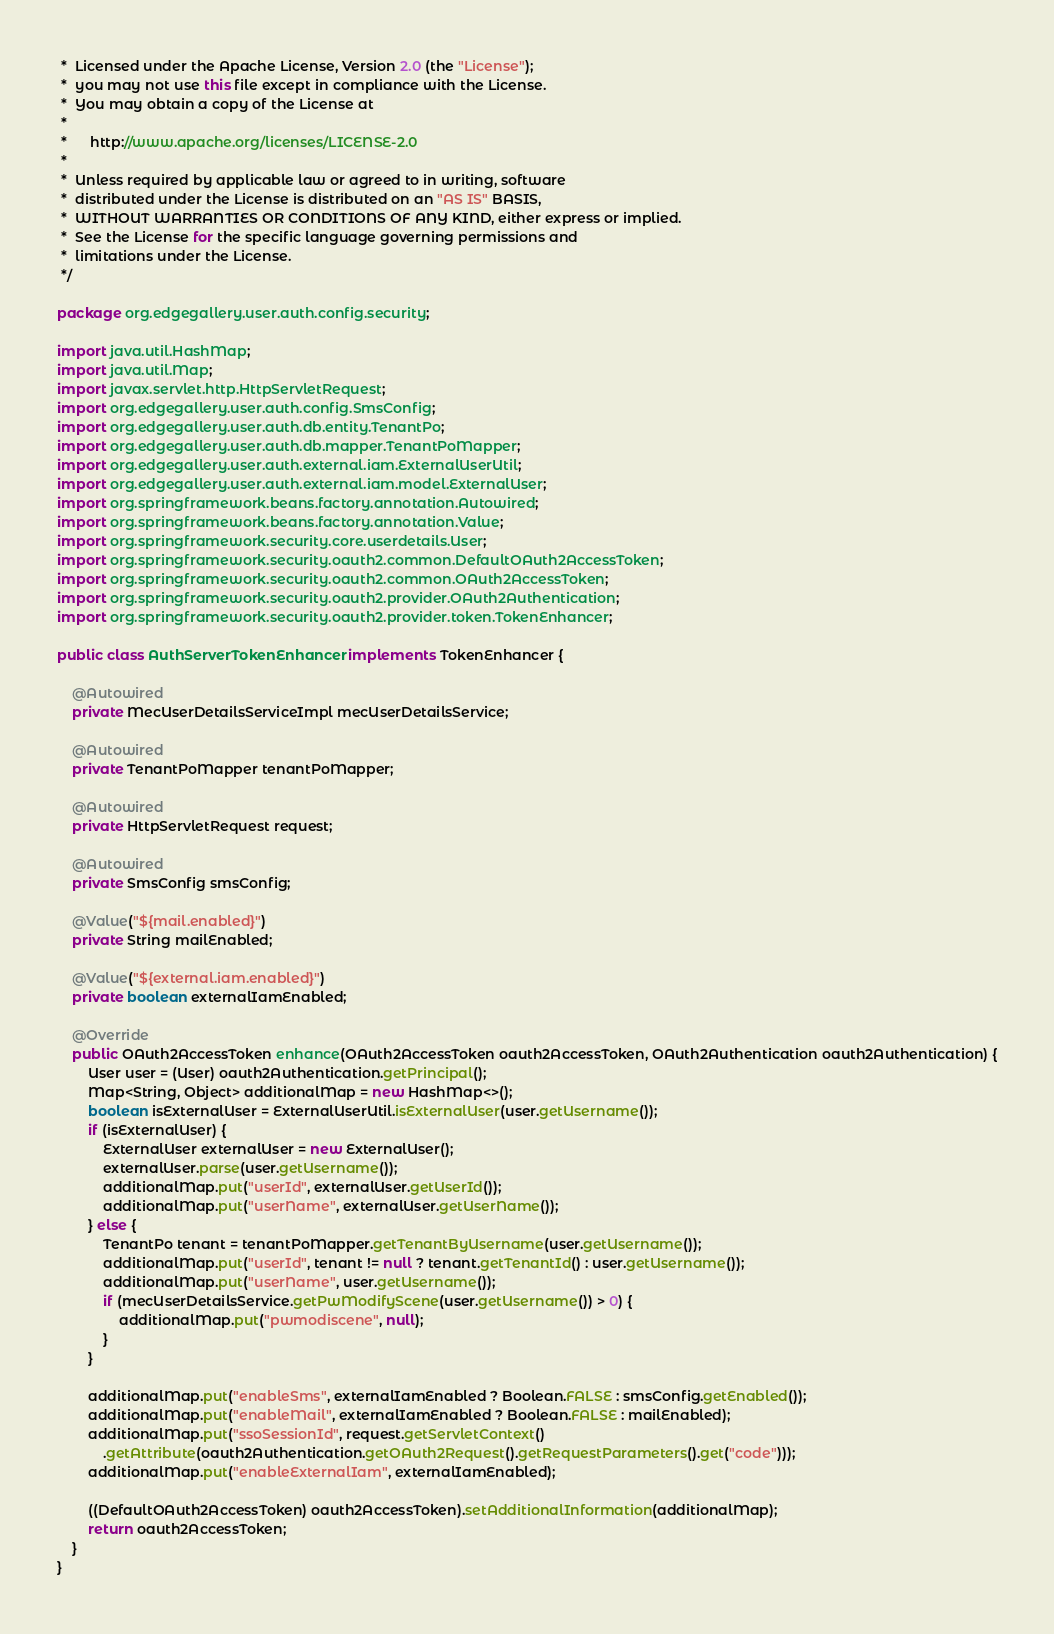Convert code to text. <code><loc_0><loc_0><loc_500><loc_500><_Java_> *  Licensed under the Apache License, Version 2.0 (the "License");
 *  you may not use this file except in compliance with the License.
 *  You may obtain a copy of the License at
 *
 *      http://www.apache.org/licenses/LICENSE-2.0
 *
 *  Unless required by applicable law or agreed to in writing, software
 *  distributed under the License is distributed on an "AS IS" BASIS,
 *  WITHOUT WARRANTIES OR CONDITIONS OF ANY KIND, either express or implied.
 *  See the License for the specific language governing permissions and
 *  limitations under the License.
 */

package org.edgegallery.user.auth.config.security;

import java.util.HashMap;
import java.util.Map;
import javax.servlet.http.HttpServletRequest;
import org.edgegallery.user.auth.config.SmsConfig;
import org.edgegallery.user.auth.db.entity.TenantPo;
import org.edgegallery.user.auth.db.mapper.TenantPoMapper;
import org.edgegallery.user.auth.external.iam.ExternalUserUtil;
import org.edgegallery.user.auth.external.iam.model.ExternalUser;
import org.springframework.beans.factory.annotation.Autowired;
import org.springframework.beans.factory.annotation.Value;
import org.springframework.security.core.userdetails.User;
import org.springframework.security.oauth2.common.DefaultOAuth2AccessToken;
import org.springframework.security.oauth2.common.OAuth2AccessToken;
import org.springframework.security.oauth2.provider.OAuth2Authentication;
import org.springframework.security.oauth2.provider.token.TokenEnhancer;

public class AuthServerTokenEnhancer implements TokenEnhancer {

    @Autowired
    private MecUserDetailsServiceImpl mecUserDetailsService;

    @Autowired
    private TenantPoMapper tenantPoMapper;

    @Autowired
    private HttpServletRequest request;

    @Autowired
    private SmsConfig smsConfig;

    @Value("${mail.enabled}")
    private String mailEnabled;

    @Value("${external.iam.enabled}")
    private boolean externalIamEnabled;

    @Override
    public OAuth2AccessToken enhance(OAuth2AccessToken oauth2AccessToken, OAuth2Authentication oauth2Authentication) {
        User user = (User) oauth2Authentication.getPrincipal();
        Map<String, Object> additionalMap = new HashMap<>();
        boolean isExternalUser = ExternalUserUtil.isExternalUser(user.getUsername());
        if (isExternalUser) {
            ExternalUser externalUser = new ExternalUser();
            externalUser.parse(user.getUsername());
            additionalMap.put("userId", externalUser.getUserId());
            additionalMap.put("userName", externalUser.getUserName());
        } else {
            TenantPo tenant = tenantPoMapper.getTenantByUsername(user.getUsername());
            additionalMap.put("userId", tenant != null ? tenant.getTenantId() : user.getUsername());
            additionalMap.put("userName", user.getUsername());
            if (mecUserDetailsService.getPwModifyScene(user.getUsername()) > 0) {
                additionalMap.put("pwmodiscene", null);
            }
        }

        additionalMap.put("enableSms", externalIamEnabled ? Boolean.FALSE : smsConfig.getEnabled());
        additionalMap.put("enableMail", externalIamEnabled ? Boolean.FALSE : mailEnabled);
        additionalMap.put("ssoSessionId", request.getServletContext()
            .getAttribute(oauth2Authentication.getOAuth2Request().getRequestParameters().get("code")));
        additionalMap.put("enableExternalIam", externalIamEnabled);

        ((DefaultOAuth2AccessToken) oauth2AccessToken).setAdditionalInformation(additionalMap);
        return oauth2AccessToken;
    }
}</code> 